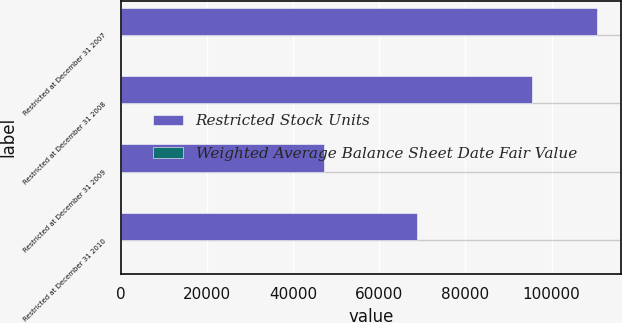Convert chart to OTSL. <chart><loc_0><loc_0><loc_500><loc_500><stacked_bar_chart><ecel><fcel>Restricted at December 31 2007<fcel>Restricted at December 31 2008<fcel>Restricted at December 31 2009<fcel>Restricted at December 31 2010<nl><fcel>Restricted Stock Units<fcel>110593<fcel>95338<fcel>47160<fcel>68791<nl><fcel>Weighted Average Balance Sheet Date Fair Value<fcel>93.04<fcel>30.26<fcel>49.76<fcel>58.71<nl></chart> 